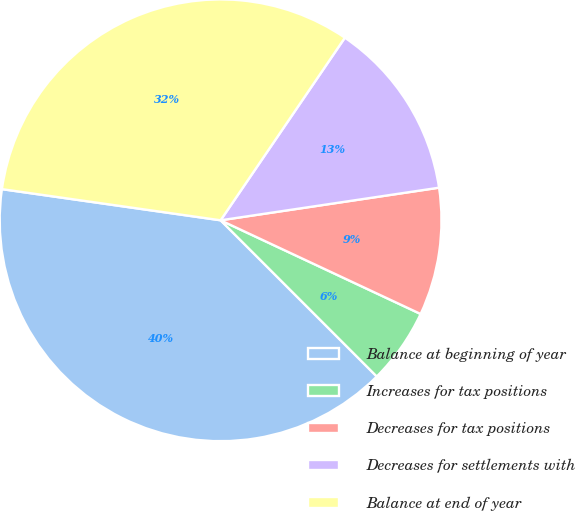<chart> <loc_0><loc_0><loc_500><loc_500><pie_chart><fcel>Balance at beginning of year<fcel>Increases for tax positions<fcel>Decreases for tax positions<fcel>Decreases for settlements with<fcel>Balance at end of year<nl><fcel>39.75%<fcel>5.53%<fcel>9.33%<fcel>13.13%<fcel>32.26%<nl></chart> 